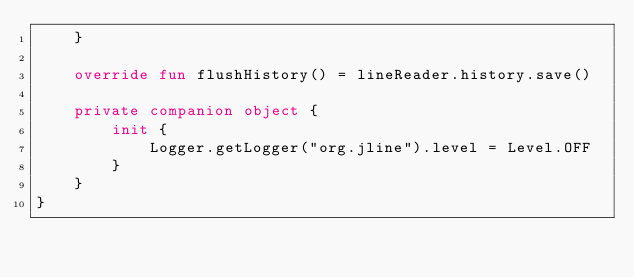Convert code to text. <code><loc_0><loc_0><loc_500><loc_500><_Kotlin_>    }

    override fun flushHistory() = lineReader.history.save()

    private companion object {
        init {
            Logger.getLogger("org.jline").level = Level.OFF
        }
    }
}
</code> 